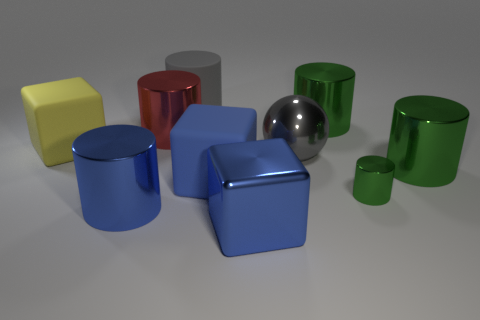Which objects in the image appear to have reflective surfaces? The sphere and the two cylinders, one red and the other metallic gray, have reflective surfaces that mirror the environment, giving them a glossy appearance. 